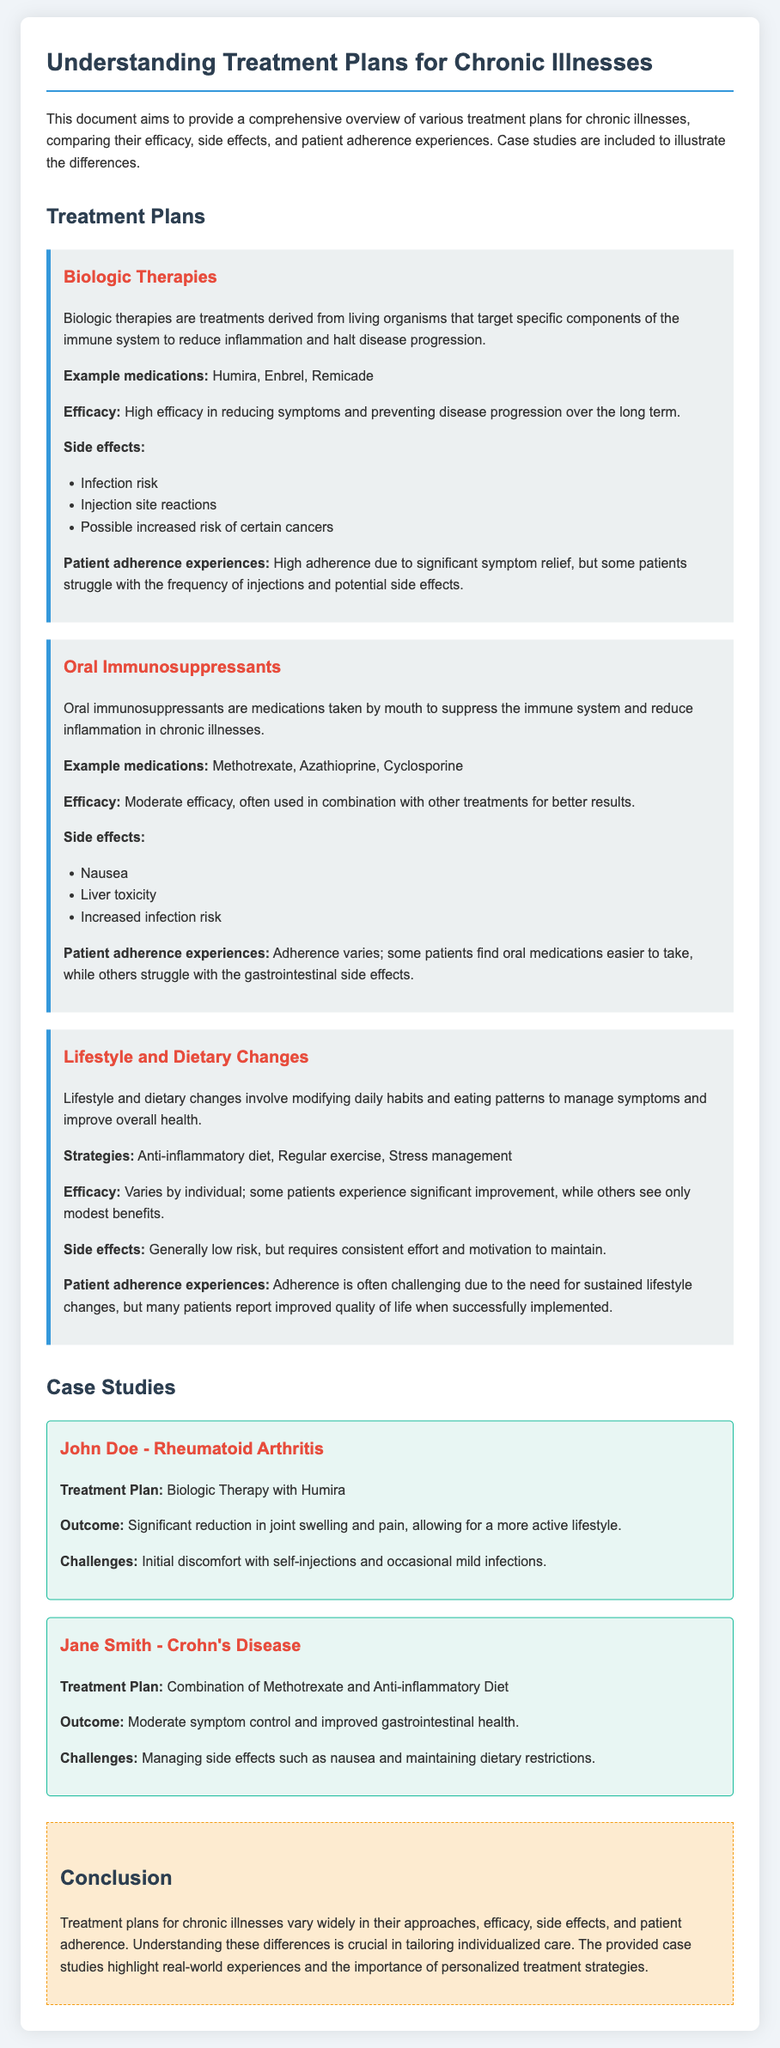What is the title of the document? The title of the document is prominently displayed at the top and indicates the main topic addressed.
Answer: Understanding Treatment Plans for Chronic Illnesses What type of therapy is Humira classified under? Humira is categorized as a biologic therapy in the document, highlighting its role in treating chronic illnesses.
Answer: Biologic Therapy What are the side effects of oral immunosuppressants? The document lists three specific side effects that are common among oral immunosuppressants.
Answer: Nausea, liver toxicity, increased infection risk Who is associated with the treatment plan using Methotrexate? The document includes a specific case study mentioning a patient using Methotrexate.
Answer: Jane Smith What is the primary challenge faced by John Doe with his treatment plan? A specific challenge related to the treatment plan implemented is noted in the case study for John Doe.
Answer: Initial discomfort with self-injections What is a key strategy mentioned for lifestyle and dietary changes? The document outlines specific strategies used to improve health through lifestyle changes for chronic illnesses.
Answer: Anti-inflammatory diet What is noted as a common patient adherence experience with biologic therapies? The document discusses a notable experience regarding adherence related to the frequency of treatment and outcomes.
Answer: High adherence due to significant symptom relief What is the overall conclusion of the document regarding treatment plans? The conclusion summarizes the varied approaches and their implications for patient care noted throughout the document.
Answer: Treatment plans for chronic illnesses vary widely in their approaches, efficacy, side effects, and patient adherence 